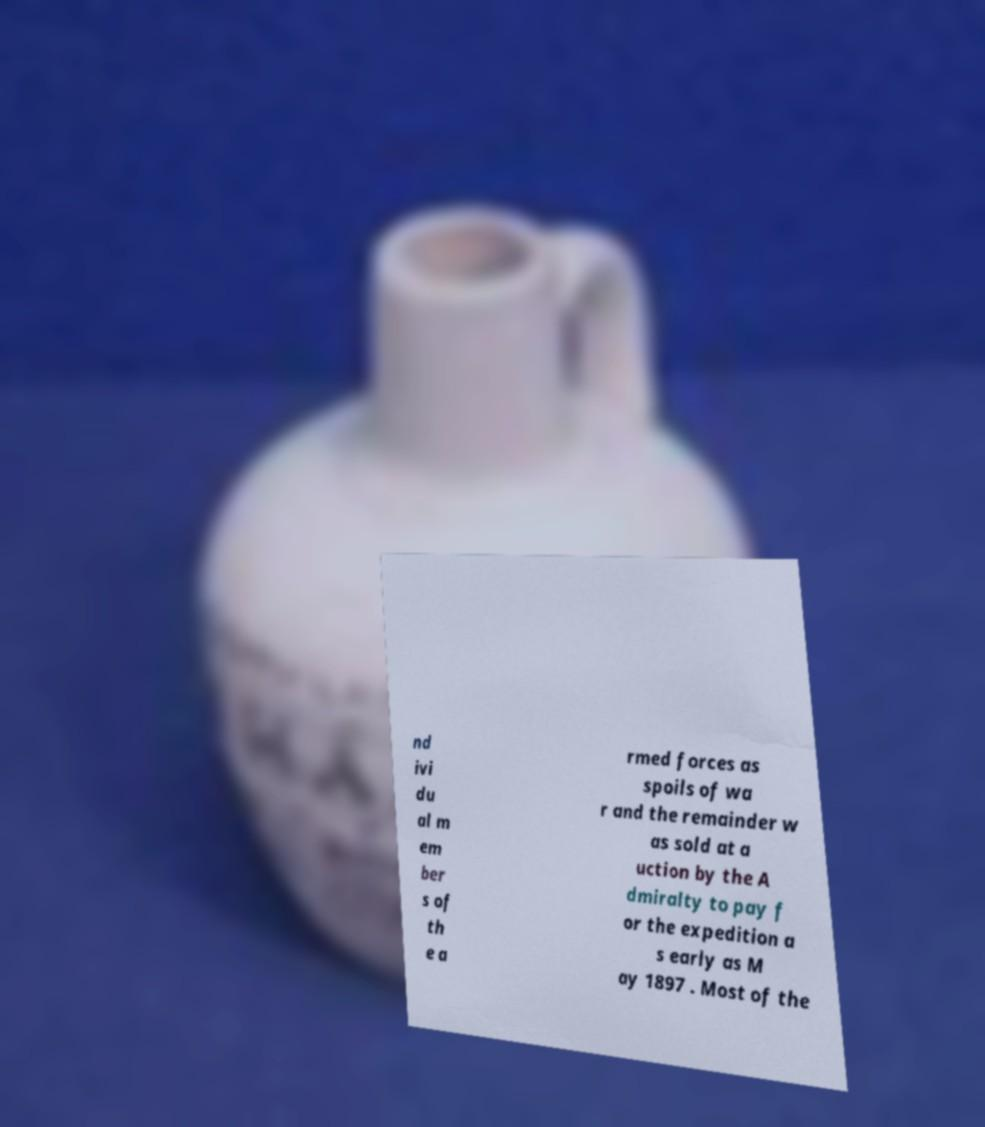Please identify and transcribe the text found in this image. nd ivi du al m em ber s of th e a rmed forces as spoils of wa r and the remainder w as sold at a uction by the A dmiralty to pay f or the expedition a s early as M ay 1897 . Most of the 